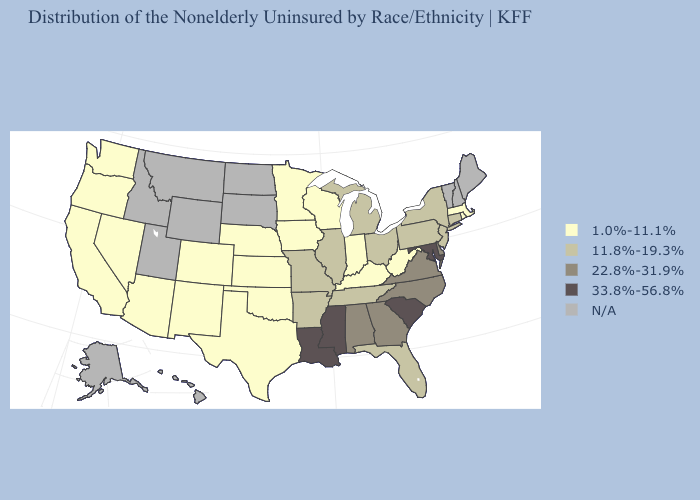What is the highest value in the USA?
Answer briefly. 33.8%-56.8%. Name the states that have a value in the range 33.8%-56.8%?
Be succinct. Louisiana, Maryland, Mississippi, South Carolina. What is the value of Arkansas?
Keep it brief. 11.8%-19.3%. What is the highest value in the West ?
Quick response, please. 1.0%-11.1%. Name the states that have a value in the range 11.8%-19.3%?
Give a very brief answer. Arkansas, Connecticut, Florida, Illinois, Michigan, Missouri, New Jersey, New York, Ohio, Pennsylvania, Tennessee. Name the states that have a value in the range N/A?
Short answer required. Alaska, Hawaii, Idaho, Maine, Montana, New Hampshire, North Dakota, South Dakota, Utah, Vermont, Wyoming. What is the lowest value in states that border Arkansas?
Answer briefly. 1.0%-11.1%. Does South Carolina have the highest value in the USA?
Keep it brief. Yes. Name the states that have a value in the range N/A?
Short answer required. Alaska, Hawaii, Idaho, Maine, Montana, New Hampshire, North Dakota, South Dakota, Utah, Vermont, Wyoming. What is the value of Kansas?
Keep it brief. 1.0%-11.1%. Among the states that border Nebraska , which have the highest value?
Be succinct. Missouri. Among the states that border Louisiana , which have the highest value?
Keep it brief. Mississippi. What is the highest value in states that border Arkansas?
Keep it brief. 33.8%-56.8%. 